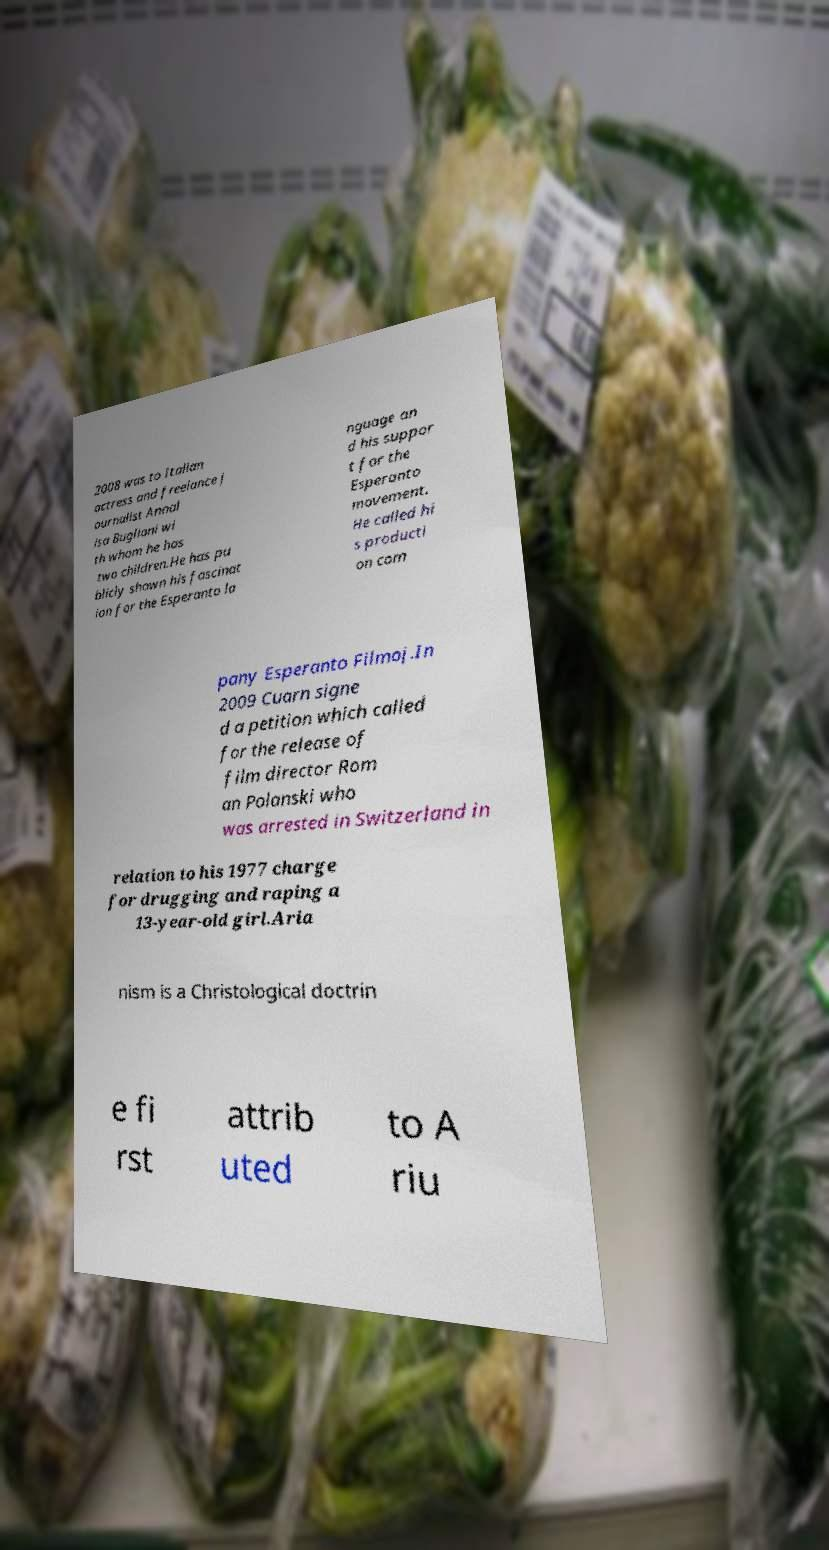What messages or text are displayed in this image? I need them in a readable, typed format. 2008 was to Italian actress and freelance j ournalist Annal isa Bugliani wi th whom he has two children.He has pu blicly shown his fascinat ion for the Esperanto la nguage an d his suppor t for the Esperanto movement. He called hi s producti on com pany Esperanto Filmoj.In 2009 Cuarn signe d a petition which called for the release of film director Rom an Polanski who was arrested in Switzerland in relation to his 1977 charge for drugging and raping a 13-year-old girl.Aria nism is a Christological doctrin e fi rst attrib uted to A riu 